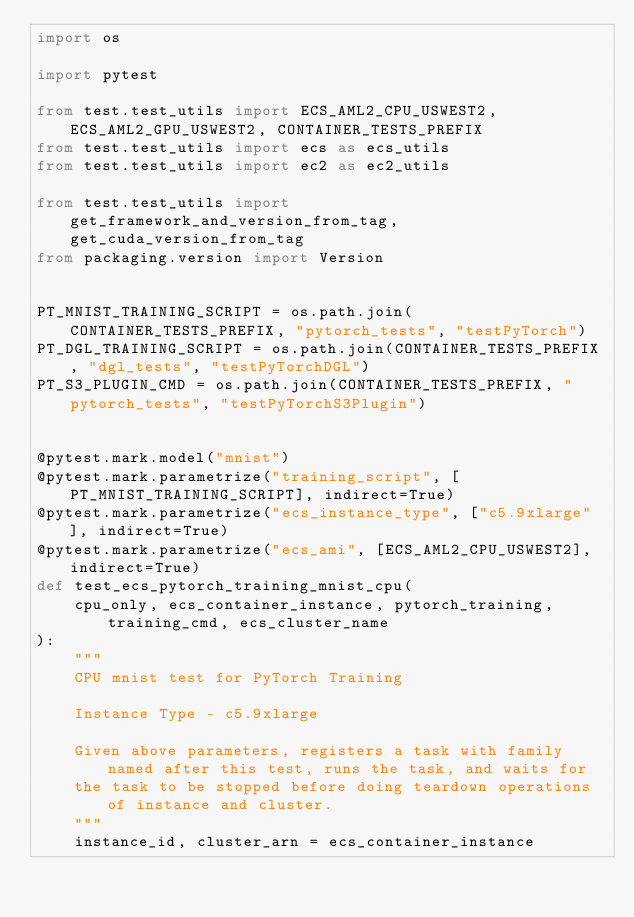Convert code to text. <code><loc_0><loc_0><loc_500><loc_500><_Python_>import os

import pytest

from test.test_utils import ECS_AML2_CPU_USWEST2, ECS_AML2_GPU_USWEST2, CONTAINER_TESTS_PREFIX
from test.test_utils import ecs as ecs_utils
from test.test_utils import ec2 as ec2_utils

from test.test_utils import get_framework_and_version_from_tag, get_cuda_version_from_tag
from packaging.version import Version


PT_MNIST_TRAINING_SCRIPT = os.path.join(CONTAINER_TESTS_PREFIX, "pytorch_tests", "testPyTorch")
PT_DGL_TRAINING_SCRIPT = os.path.join(CONTAINER_TESTS_PREFIX, "dgl_tests", "testPyTorchDGL")
PT_S3_PLUGIN_CMD = os.path.join(CONTAINER_TESTS_PREFIX, "pytorch_tests", "testPyTorchS3Plugin")


@pytest.mark.model("mnist")
@pytest.mark.parametrize("training_script", [PT_MNIST_TRAINING_SCRIPT], indirect=True)
@pytest.mark.parametrize("ecs_instance_type", ["c5.9xlarge"], indirect=True)
@pytest.mark.parametrize("ecs_ami", [ECS_AML2_CPU_USWEST2], indirect=True)
def test_ecs_pytorch_training_mnist_cpu(
    cpu_only, ecs_container_instance, pytorch_training, training_cmd, ecs_cluster_name
):
    """
    CPU mnist test for PyTorch Training

    Instance Type - c5.9xlarge

    Given above parameters, registers a task with family named after this test, runs the task, and waits for
    the task to be stopped before doing teardown operations of instance and cluster.
    """
    instance_id, cluster_arn = ecs_container_instance
</code> 